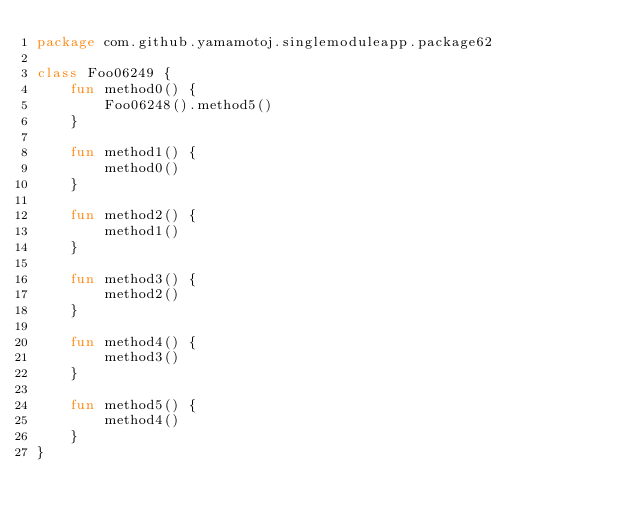Convert code to text. <code><loc_0><loc_0><loc_500><loc_500><_Kotlin_>package com.github.yamamotoj.singlemoduleapp.package62

class Foo06249 {
    fun method0() {
        Foo06248().method5()
    }

    fun method1() {
        method0()
    }

    fun method2() {
        method1()
    }

    fun method3() {
        method2()
    }

    fun method4() {
        method3()
    }

    fun method5() {
        method4()
    }
}
</code> 